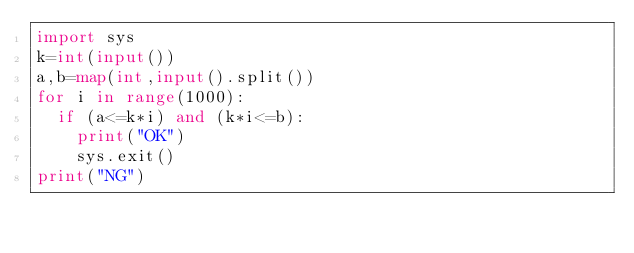<code> <loc_0><loc_0><loc_500><loc_500><_Python_>import sys
k=int(input())
a,b=map(int,input().split())
for i in range(1000):
  if (a<=k*i) and (k*i<=b):
    print("OK")
    sys.exit()
print("NG")</code> 